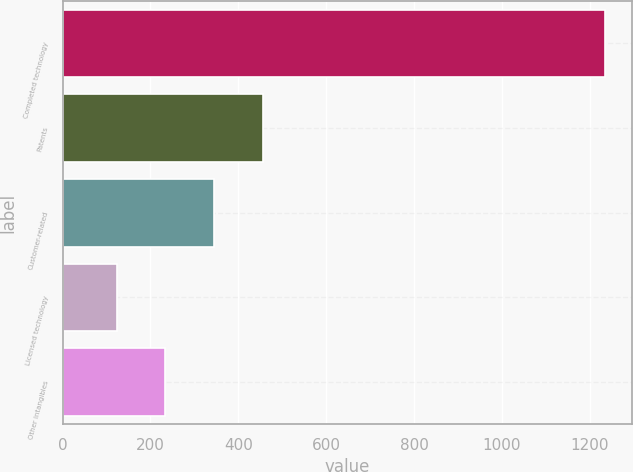<chart> <loc_0><loc_0><loc_500><loc_500><bar_chart><fcel>Completed technology<fcel>Patents<fcel>Customer-related<fcel>Licensed technology<fcel>Other intangibles<nl><fcel>1234<fcel>456.3<fcel>345.2<fcel>123<fcel>234.1<nl></chart> 